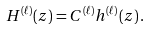Convert formula to latex. <formula><loc_0><loc_0><loc_500><loc_500>H ^ { ( \ell ) } ( z ) = C ^ { ( \ell ) } h ^ { ( \ell ) } ( z ) \, .</formula> 